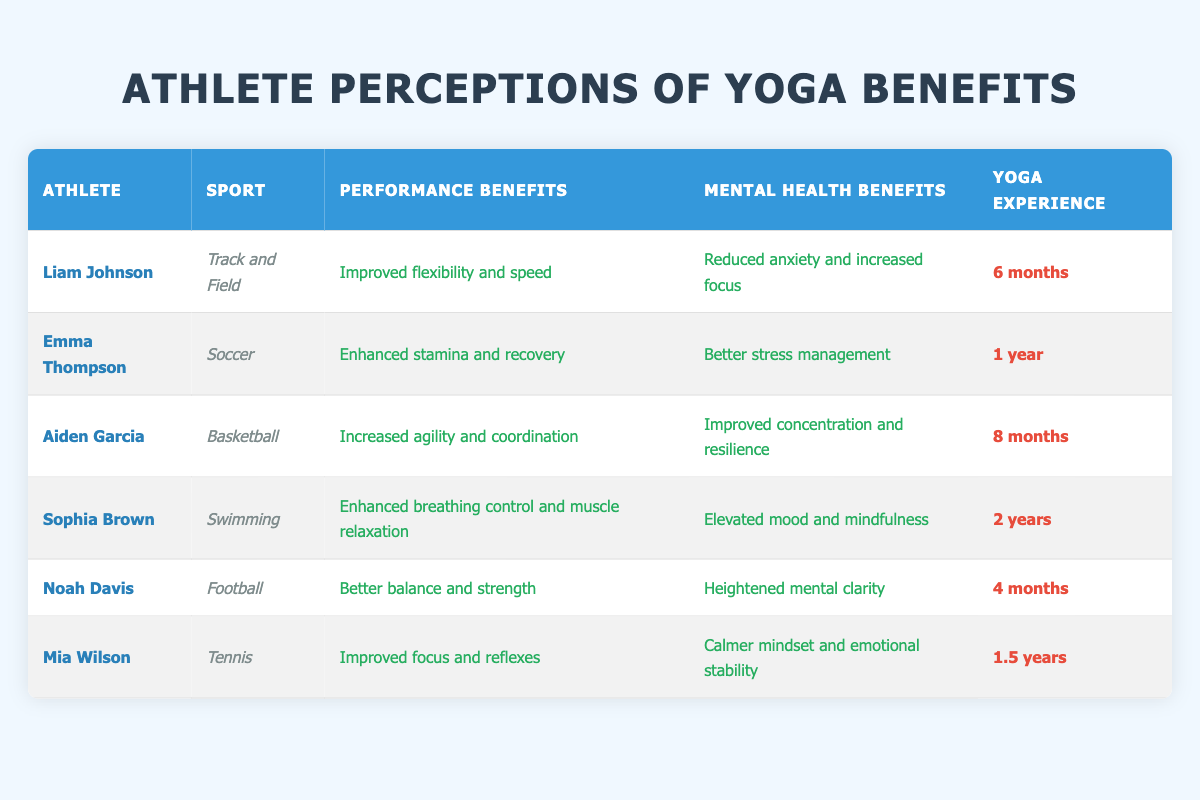What are the perceived performance benefits for Emma Thompson? The table shows that Emma Thompson's perceived performance benefits are "Enhanced stamina and recovery."
Answer: Enhanced stamina and recovery How many months of yoga experience does Aiden Garcia have? According to the table, Aiden Garcia has "8 months" of yoga experience.
Answer: 8 months Which athlete has reported "Improved concentration and resilience" as a mental health benefit? Aiden Garcia has reported "Improved concentration and resilience" as a mental health benefit, as stated in the table under his entry.
Answer: Aiden Garcia Who among the athletes has the longest yoga experience? The table indicates that Sophia Brown has the longest yoga experience, with "2 years."
Answer: Sophia Brown Is it true that Noah Davis has reported enhanced breathing control as a performance benefit? The table shows that Noah Davis's performance benefits are "Better balance and strength," so it is false that he reported enhanced breathing control.
Answer: False What is the average length of yoga experience among the athletes listed? The yoga experience for each athlete is: 6 months (0.5), 12 months (1), 8 months (0.67), 24 months (2), 4 months (0.33), and 18 months (1.5). First, convert all months to years: 0.5, 1, 0.67, 2, 0.33, and 1.5. Summing these values gives 7.0 years. Dividing by the number of athletes (6) gives an average of 7.0/6 = 1.17 years.
Answer: 1.17 years Which sport did Liam Johnson participate in? From the table, it is clear that Liam Johnson participated in "Track and Field."
Answer: Track and Field Which athlete reported the mental health benefit of a "calmer mindset and emotional stability"? The table states that Mia Wilson reported the mental health benefit of a "calmer mindset and emotional stability."
Answer: Mia Wilson Are there any athletes with less than one year of yoga experience who reported mental health benefits related to anxiety? Looking at the table, Noah Davis has 4 months of yoga experience and reported "Heightened mental clarity," while Liam Johnson—who has 6 months of yoga experience—reported "Reduced anxiety and increased focus." Thus, there are athletes with less than a year who reported mental health benefits related to anxiety.
Answer: Yes 